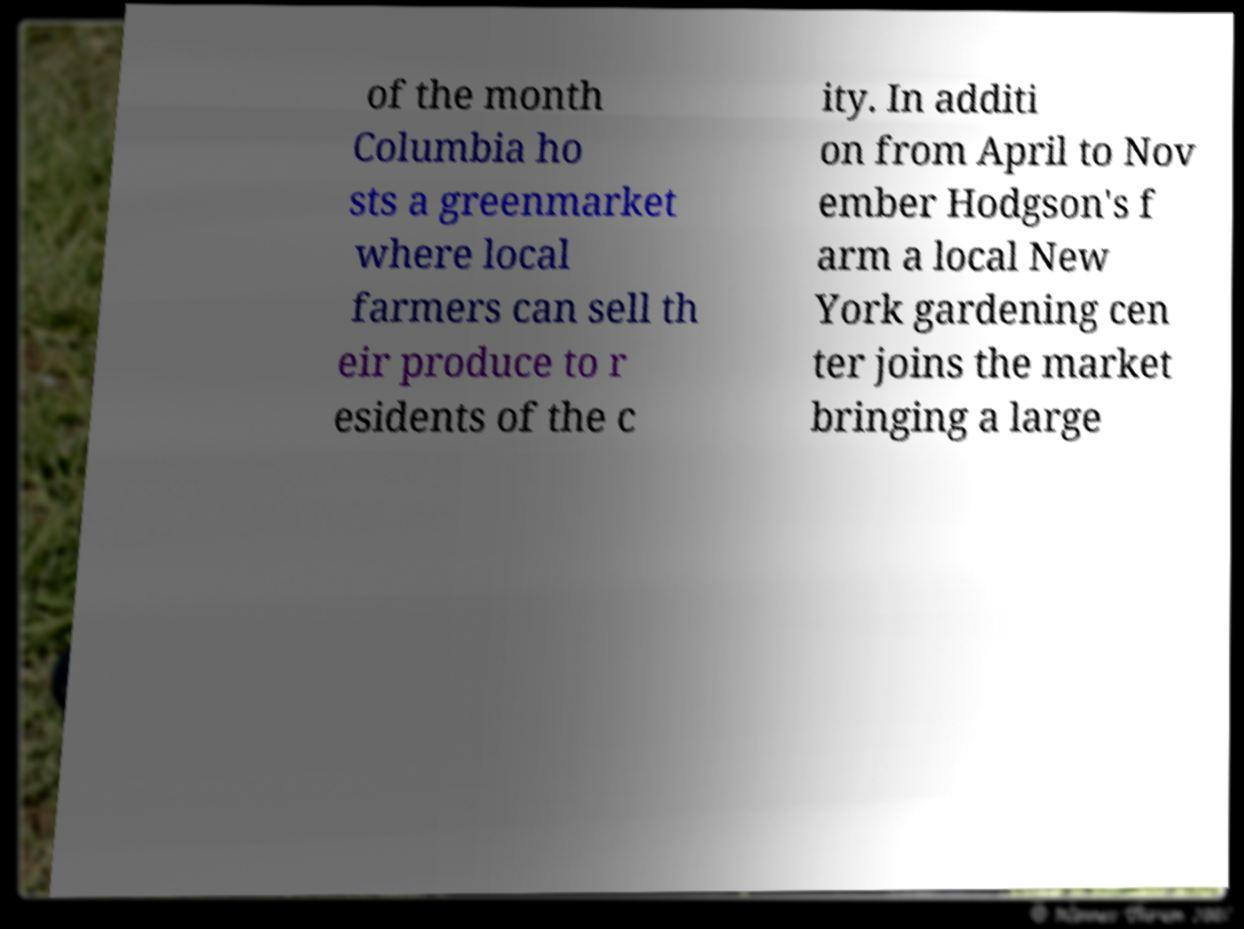For documentation purposes, I need the text within this image transcribed. Could you provide that? of the month Columbia ho sts a greenmarket where local farmers can sell th eir produce to r esidents of the c ity. In additi on from April to Nov ember Hodgson's f arm a local New York gardening cen ter joins the market bringing a large 